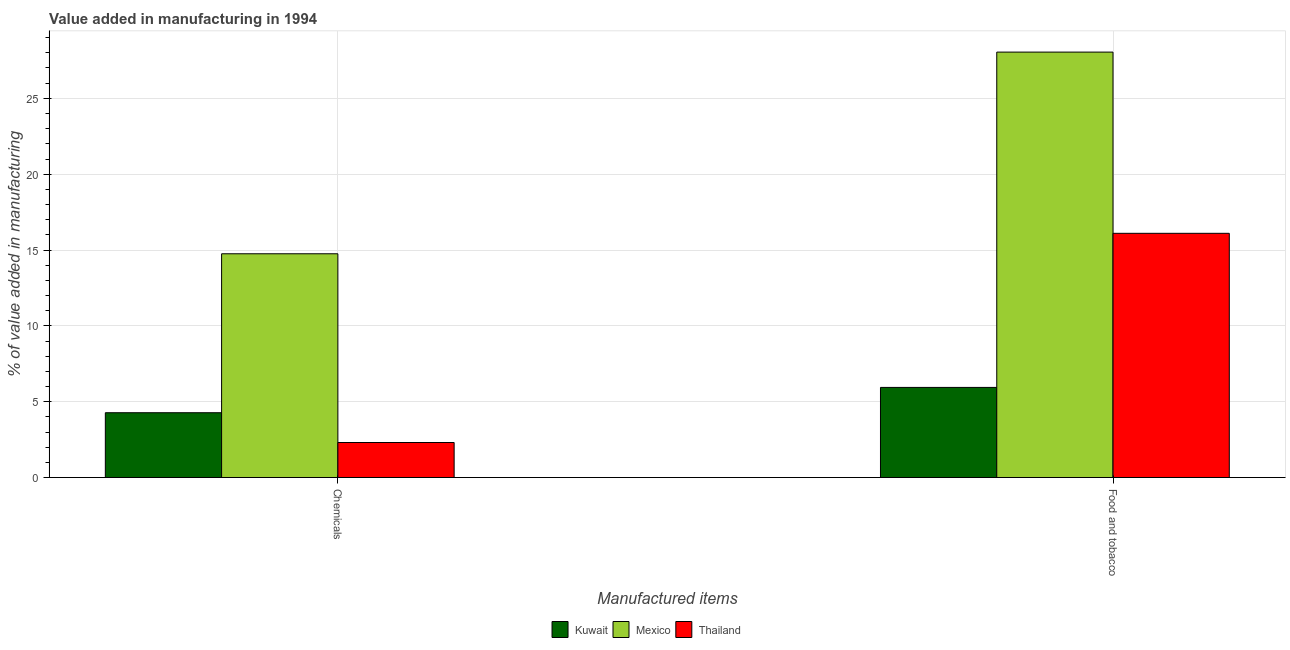How many different coloured bars are there?
Your answer should be very brief. 3. Are the number of bars on each tick of the X-axis equal?
Your answer should be very brief. Yes. How many bars are there on the 1st tick from the left?
Make the answer very short. 3. What is the label of the 2nd group of bars from the left?
Offer a terse response. Food and tobacco. What is the value added by  manufacturing chemicals in Mexico?
Offer a terse response. 14.75. Across all countries, what is the maximum value added by  manufacturing chemicals?
Offer a terse response. 14.75. Across all countries, what is the minimum value added by  manufacturing chemicals?
Provide a short and direct response. 2.31. In which country was the value added by manufacturing food and tobacco maximum?
Provide a short and direct response. Mexico. In which country was the value added by  manufacturing chemicals minimum?
Offer a very short reply. Thailand. What is the total value added by manufacturing food and tobacco in the graph?
Offer a very short reply. 50.09. What is the difference between the value added by manufacturing food and tobacco in Kuwait and that in Thailand?
Offer a very short reply. -10.16. What is the difference between the value added by manufacturing food and tobacco in Kuwait and the value added by  manufacturing chemicals in Thailand?
Offer a terse response. 3.63. What is the average value added by  manufacturing chemicals per country?
Your response must be concise. 7.11. What is the difference between the value added by  manufacturing chemicals and value added by manufacturing food and tobacco in Thailand?
Provide a succinct answer. -13.79. What is the ratio of the value added by  manufacturing chemicals in Mexico to that in Kuwait?
Give a very brief answer. 3.45. In how many countries, is the value added by manufacturing food and tobacco greater than the average value added by manufacturing food and tobacco taken over all countries?
Ensure brevity in your answer.  1. What does the 3rd bar from the left in Chemicals represents?
Offer a very short reply. Thailand. How many bars are there?
Your response must be concise. 6. How many countries are there in the graph?
Keep it short and to the point. 3. Are the values on the major ticks of Y-axis written in scientific E-notation?
Provide a succinct answer. No. Does the graph contain any zero values?
Ensure brevity in your answer.  No. Does the graph contain grids?
Offer a terse response. Yes. Where does the legend appear in the graph?
Give a very brief answer. Bottom center. How many legend labels are there?
Keep it short and to the point. 3. What is the title of the graph?
Provide a short and direct response. Value added in manufacturing in 1994. What is the label or title of the X-axis?
Offer a very short reply. Manufactured items. What is the label or title of the Y-axis?
Keep it short and to the point. % of value added in manufacturing. What is the % of value added in manufacturing of Kuwait in Chemicals?
Give a very brief answer. 4.27. What is the % of value added in manufacturing in Mexico in Chemicals?
Your answer should be very brief. 14.75. What is the % of value added in manufacturing of Thailand in Chemicals?
Provide a succinct answer. 2.31. What is the % of value added in manufacturing of Kuwait in Food and tobacco?
Provide a succinct answer. 5.94. What is the % of value added in manufacturing in Mexico in Food and tobacco?
Make the answer very short. 28.05. What is the % of value added in manufacturing in Thailand in Food and tobacco?
Ensure brevity in your answer.  16.1. Across all Manufactured items, what is the maximum % of value added in manufacturing in Kuwait?
Your answer should be compact. 5.94. Across all Manufactured items, what is the maximum % of value added in manufacturing in Mexico?
Provide a short and direct response. 28.05. Across all Manufactured items, what is the maximum % of value added in manufacturing of Thailand?
Give a very brief answer. 16.1. Across all Manufactured items, what is the minimum % of value added in manufacturing in Kuwait?
Your answer should be very brief. 4.27. Across all Manufactured items, what is the minimum % of value added in manufacturing of Mexico?
Provide a succinct answer. 14.75. Across all Manufactured items, what is the minimum % of value added in manufacturing in Thailand?
Ensure brevity in your answer.  2.31. What is the total % of value added in manufacturing of Kuwait in the graph?
Your answer should be very brief. 10.22. What is the total % of value added in manufacturing in Mexico in the graph?
Offer a terse response. 42.8. What is the total % of value added in manufacturing of Thailand in the graph?
Provide a succinct answer. 18.41. What is the difference between the % of value added in manufacturing of Kuwait in Chemicals and that in Food and tobacco?
Offer a very short reply. -1.67. What is the difference between the % of value added in manufacturing of Mexico in Chemicals and that in Food and tobacco?
Your response must be concise. -13.3. What is the difference between the % of value added in manufacturing in Thailand in Chemicals and that in Food and tobacco?
Ensure brevity in your answer.  -13.79. What is the difference between the % of value added in manufacturing of Kuwait in Chemicals and the % of value added in manufacturing of Mexico in Food and tobacco?
Provide a short and direct response. -23.77. What is the difference between the % of value added in manufacturing of Kuwait in Chemicals and the % of value added in manufacturing of Thailand in Food and tobacco?
Ensure brevity in your answer.  -11.83. What is the difference between the % of value added in manufacturing of Mexico in Chemicals and the % of value added in manufacturing of Thailand in Food and tobacco?
Your answer should be very brief. -1.35. What is the average % of value added in manufacturing in Kuwait per Manufactured items?
Offer a terse response. 5.11. What is the average % of value added in manufacturing in Mexico per Manufactured items?
Give a very brief answer. 21.4. What is the average % of value added in manufacturing of Thailand per Manufactured items?
Your response must be concise. 9.21. What is the difference between the % of value added in manufacturing of Kuwait and % of value added in manufacturing of Mexico in Chemicals?
Your answer should be compact. -10.48. What is the difference between the % of value added in manufacturing in Kuwait and % of value added in manufacturing in Thailand in Chemicals?
Ensure brevity in your answer.  1.96. What is the difference between the % of value added in manufacturing in Mexico and % of value added in manufacturing in Thailand in Chemicals?
Provide a short and direct response. 12.44. What is the difference between the % of value added in manufacturing in Kuwait and % of value added in manufacturing in Mexico in Food and tobacco?
Provide a short and direct response. -22.1. What is the difference between the % of value added in manufacturing of Kuwait and % of value added in manufacturing of Thailand in Food and tobacco?
Provide a succinct answer. -10.16. What is the difference between the % of value added in manufacturing of Mexico and % of value added in manufacturing of Thailand in Food and tobacco?
Give a very brief answer. 11.95. What is the ratio of the % of value added in manufacturing of Kuwait in Chemicals to that in Food and tobacco?
Give a very brief answer. 0.72. What is the ratio of the % of value added in manufacturing in Mexico in Chemicals to that in Food and tobacco?
Provide a short and direct response. 0.53. What is the ratio of the % of value added in manufacturing of Thailand in Chemicals to that in Food and tobacco?
Provide a succinct answer. 0.14. What is the difference between the highest and the second highest % of value added in manufacturing of Kuwait?
Offer a very short reply. 1.67. What is the difference between the highest and the second highest % of value added in manufacturing in Mexico?
Give a very brief answer. 13.3. What is the difference between the highest and the second highest % of value added in manufacturing in Thailand?
Give a very brief answer. 13.79. What is the difference between the highest and the lowest % of value added in manufacturing of Kuwait?
Give a very brief answer. 1.67. What is the difference between the highest and the lowest % of value added in manufacturing of Mexico?
Offer a terse response. 13.3. What is the difference between the highest and the lowest % of value added in manufacturing of Thailand?
Provide a short and direct response. 13.79. 